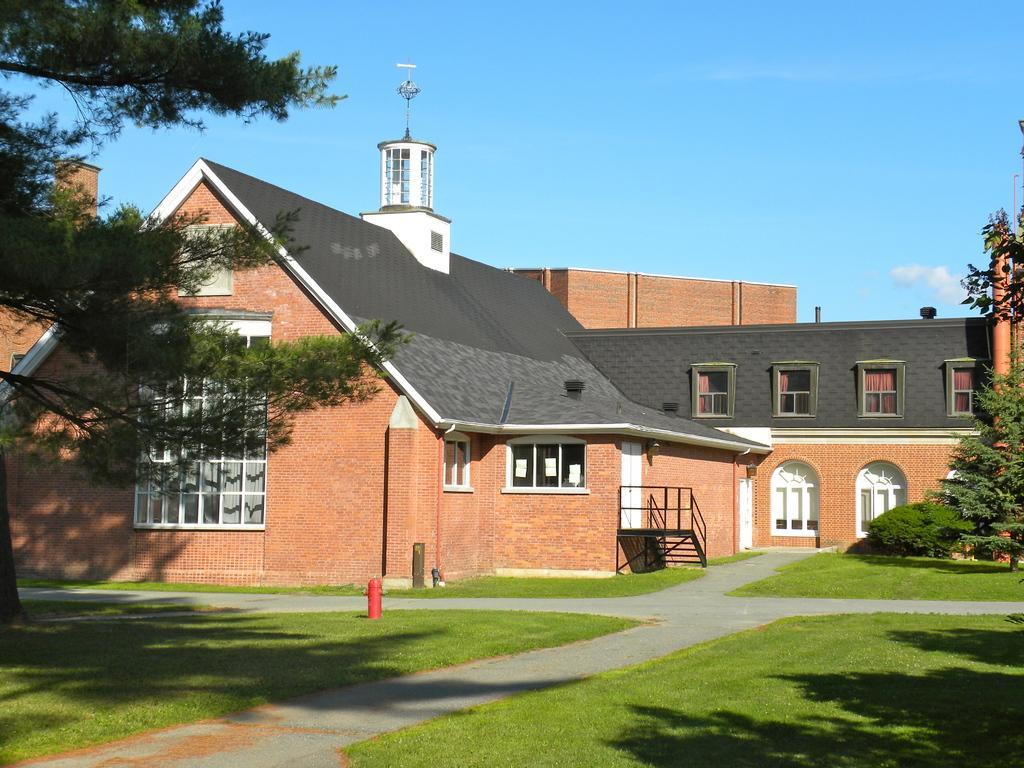Could you give a brief overview of what you see in this image? In this image in the center there is grass on the ground and there is a fire hydrant which is red in colour. In the background there are buildings, there are trees and there is a staircase which is black in colour. 